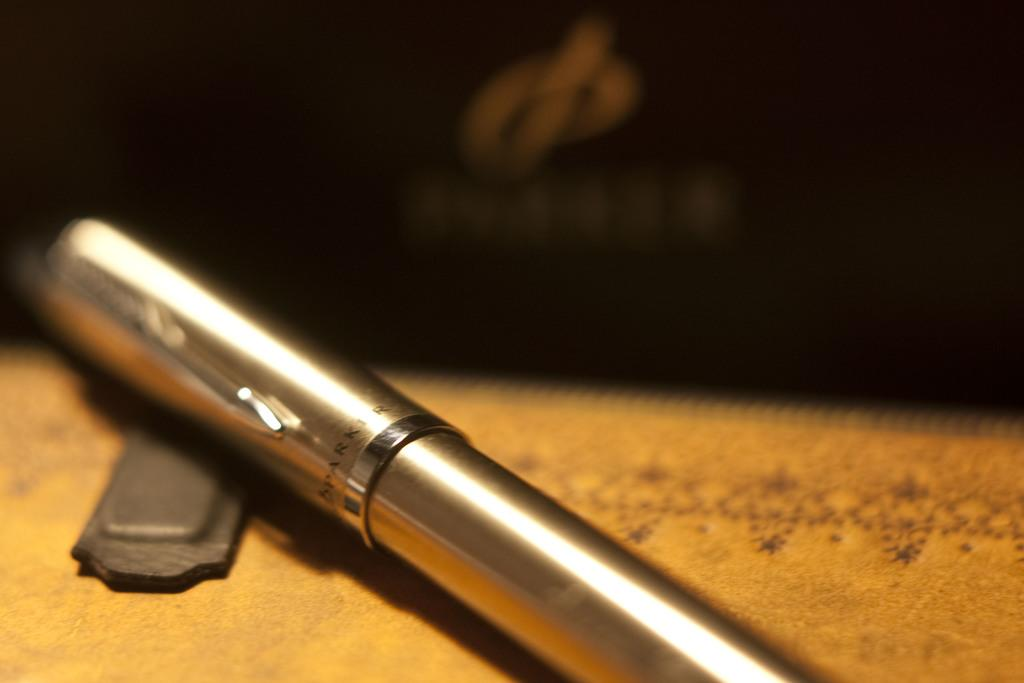What type of writing instrument is in the image? There is a metal pen in the image. Where is the metal pen located? The metal pen is on the floor. What type of sheet is covering the hospital bed in the image? There is no sheet or hospital bed present in the image; it only features a metal pen on the floor. 